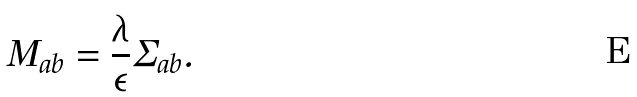Convert formula to latex. <formula><loc_0><loc_0><loc_500><loc_500>M _ { a b } = \frac { \lambda } { \epsilon } \Sigma _ { a b } .</formula> 